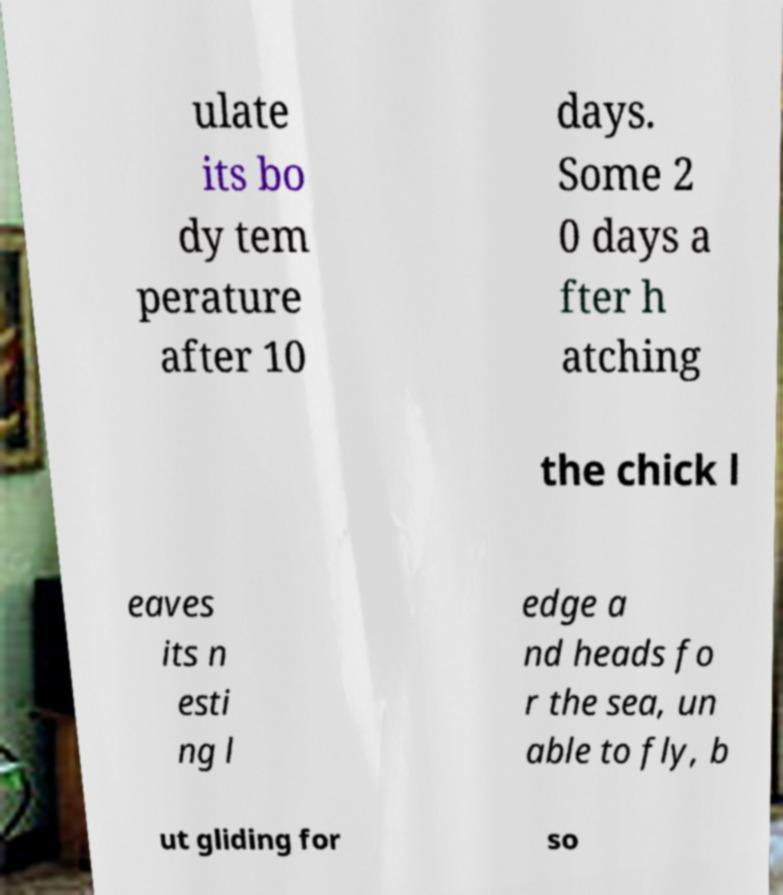Can you read and provide the text displayed in the image?This photo seems to have some interesting text. Can you extract and type it out for me? ulate its bo dy tem perature after 10 days. Some 2 0 days a fter h atching the chick l eaves its n esti ng l edge a nd heads fo r the sea, un able to fly, b ut gliding for so 